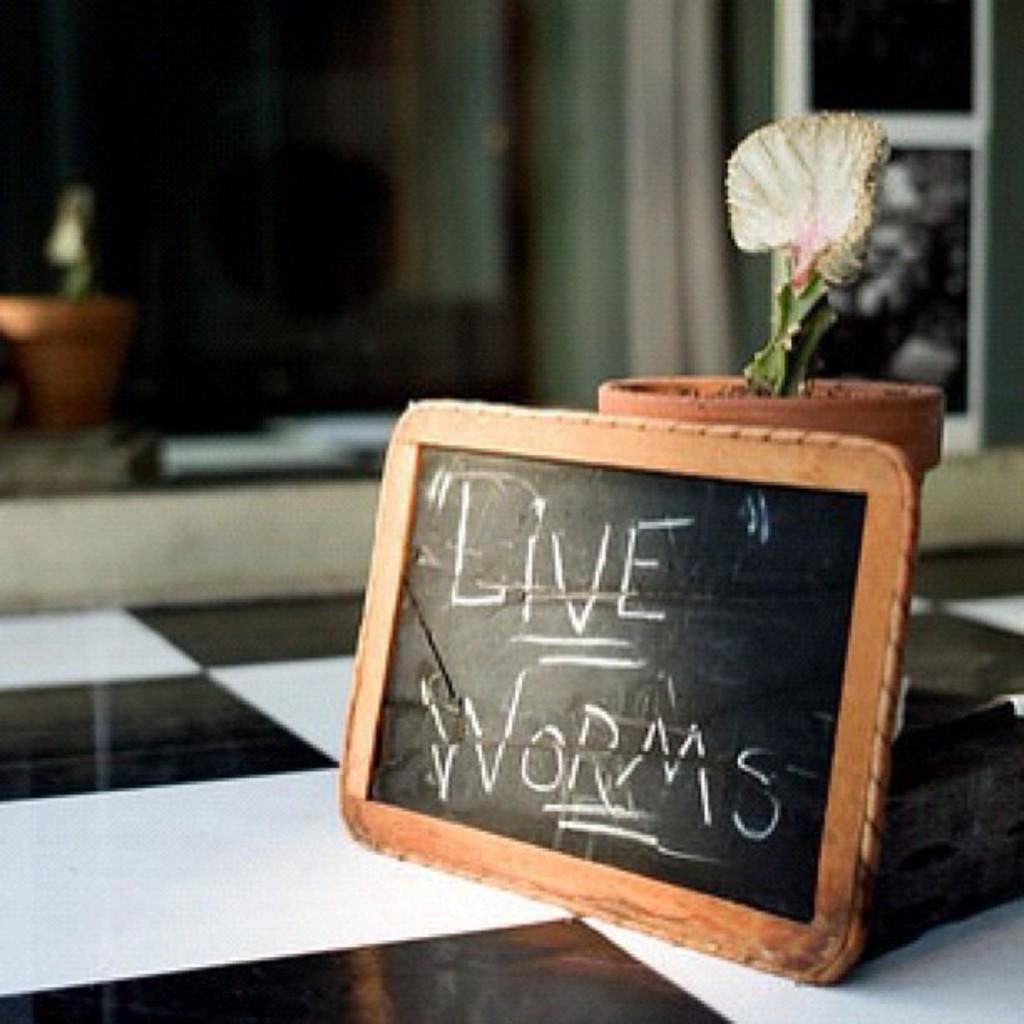Can you describe this image briefly? In this picture we can see some text on a slate and a house plant is visible on the floor. We can see a few objects in the background. Background is blurry. 